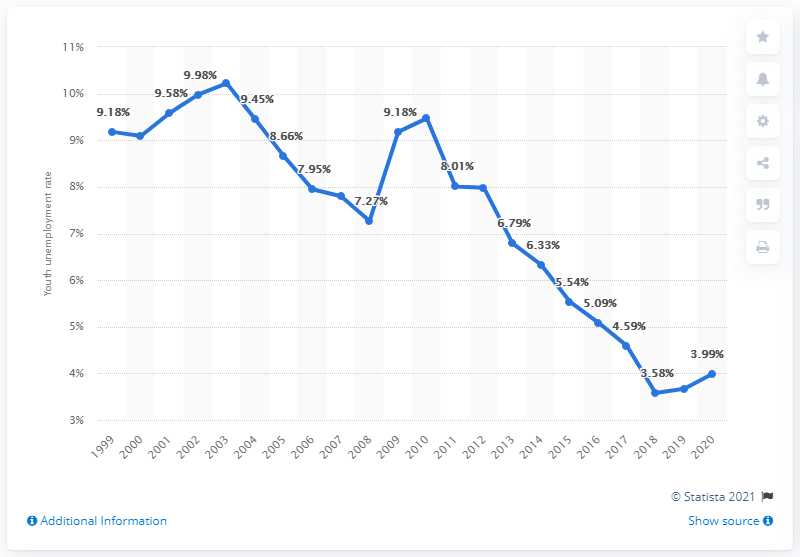Draw attention to some important aspects in this diagram. In 2020, the youth unemployment rate in Japan was 3.99%. 